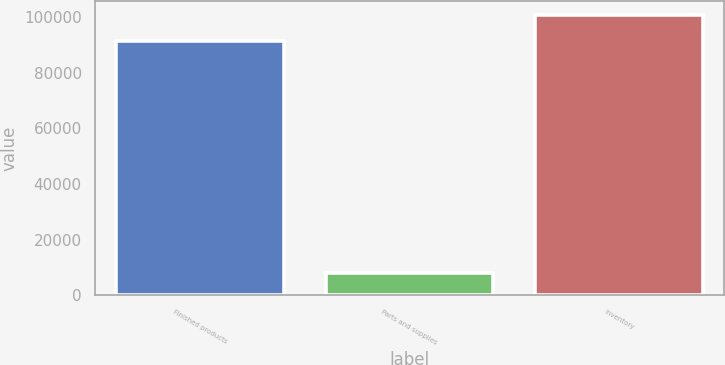Convert chart. <chart><loc_0><loc_0><loc_500><loc_500><bar_chart><fcel>Finished products<fcel>Parts and supplies<fcel>Inventory<nl><fcel>91512<fcel>7819<fcel>100663<nl></chart> 